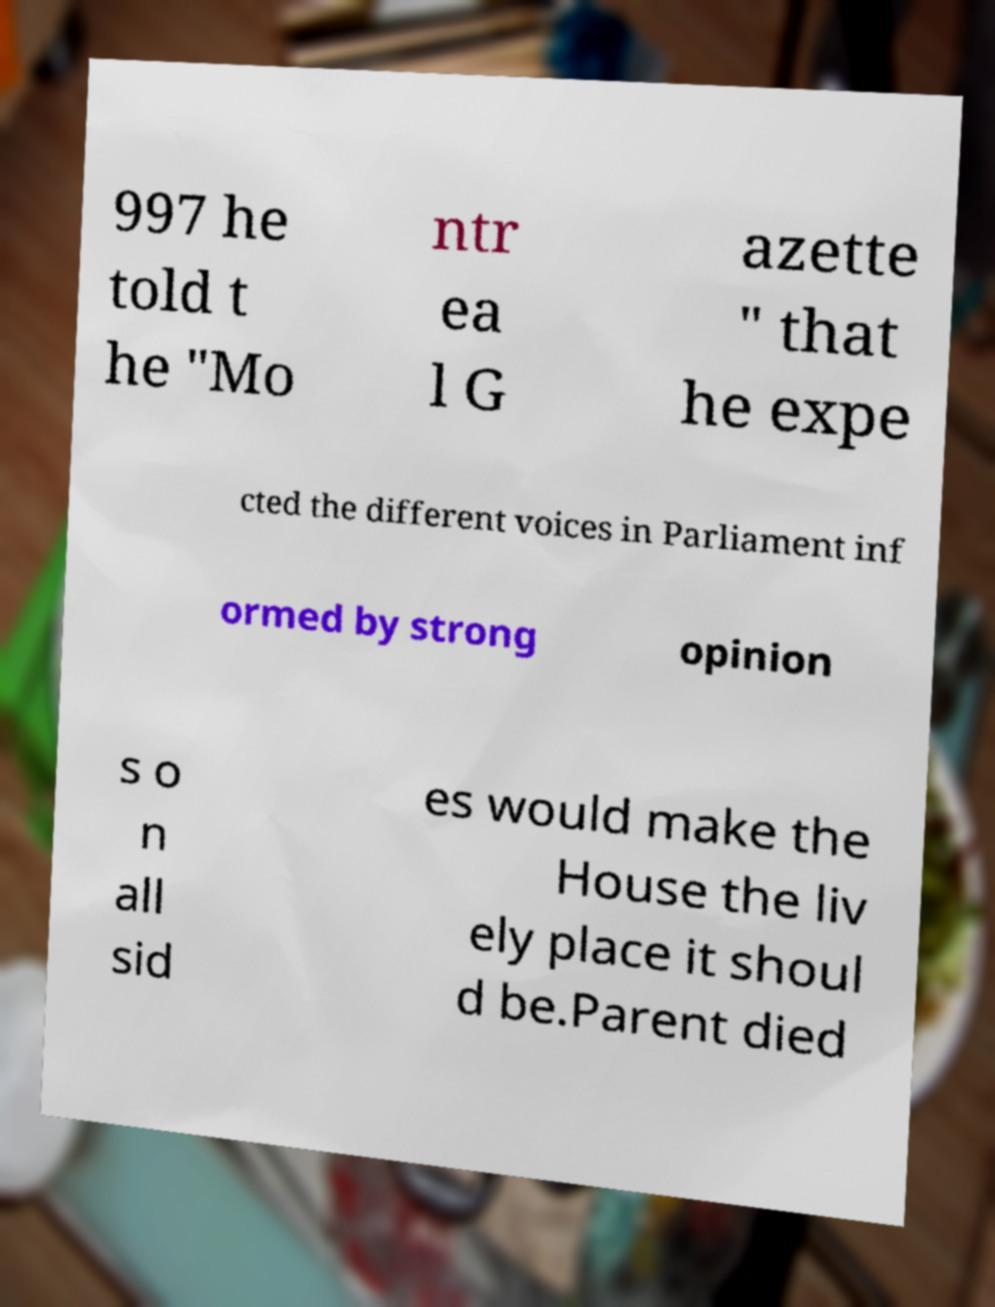Can you read and provide the text displayed in the image?This photo seems to have some interesting text. Can you extract and type it out for me? 997 he told t he "Mo ntr ea l G azette " that he expe cted the different voices in Parliament inf ormed by strong opinion s o n all sid es would make the House the liv ely place it shoul d be.Parent died 